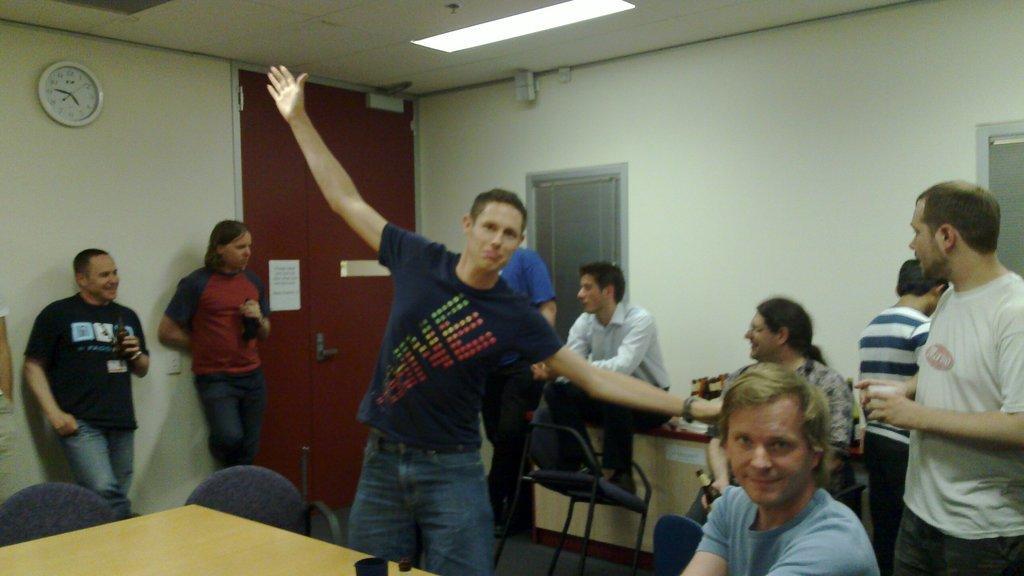Could you give a brief overview of what you see in this image? In this image, in the middle we can see a man standing, on the right side there is a man sitting on a chair, we can see some people standing, we can see the walls and a door, on the left side top there is a clock on the wall, at the top we can see the roof. 